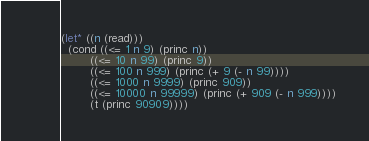<code> <loc_0><loc_0><loc_500><loc_500><_Lisp_>(let* ((n (read)))
  (cond ((<= 1 n 9) (princ n))
        ((<= 10 n 99) (princ 9))
        ((<= 100 n 999) (princ (+ 9 (- n 99))))
        ((<= 1000 n 9999) (princ 909))
        ((<= 10000 n 99999) (princ (+ 909 (- n 999))))
        (t (princ 90909))))</code> 